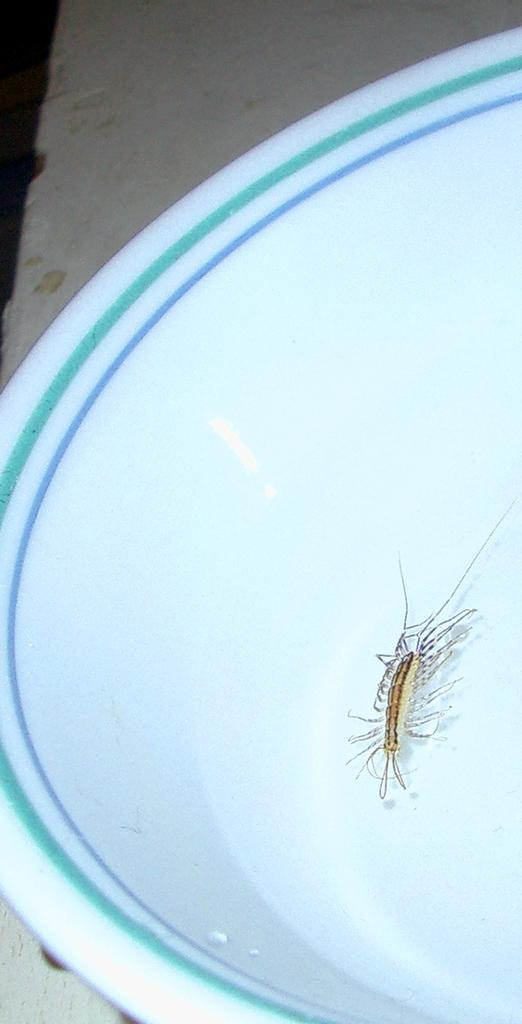What type of creature is in the image? There is an insect in the image. Where is the insect located? The insect is in the water. What is the water contained in? The water is in a bowl. How far away from the ocean is the insect in the image? The image does not provide any information about the distance from the ocean, and the insect is in a bowl of water, not near the ocean. 